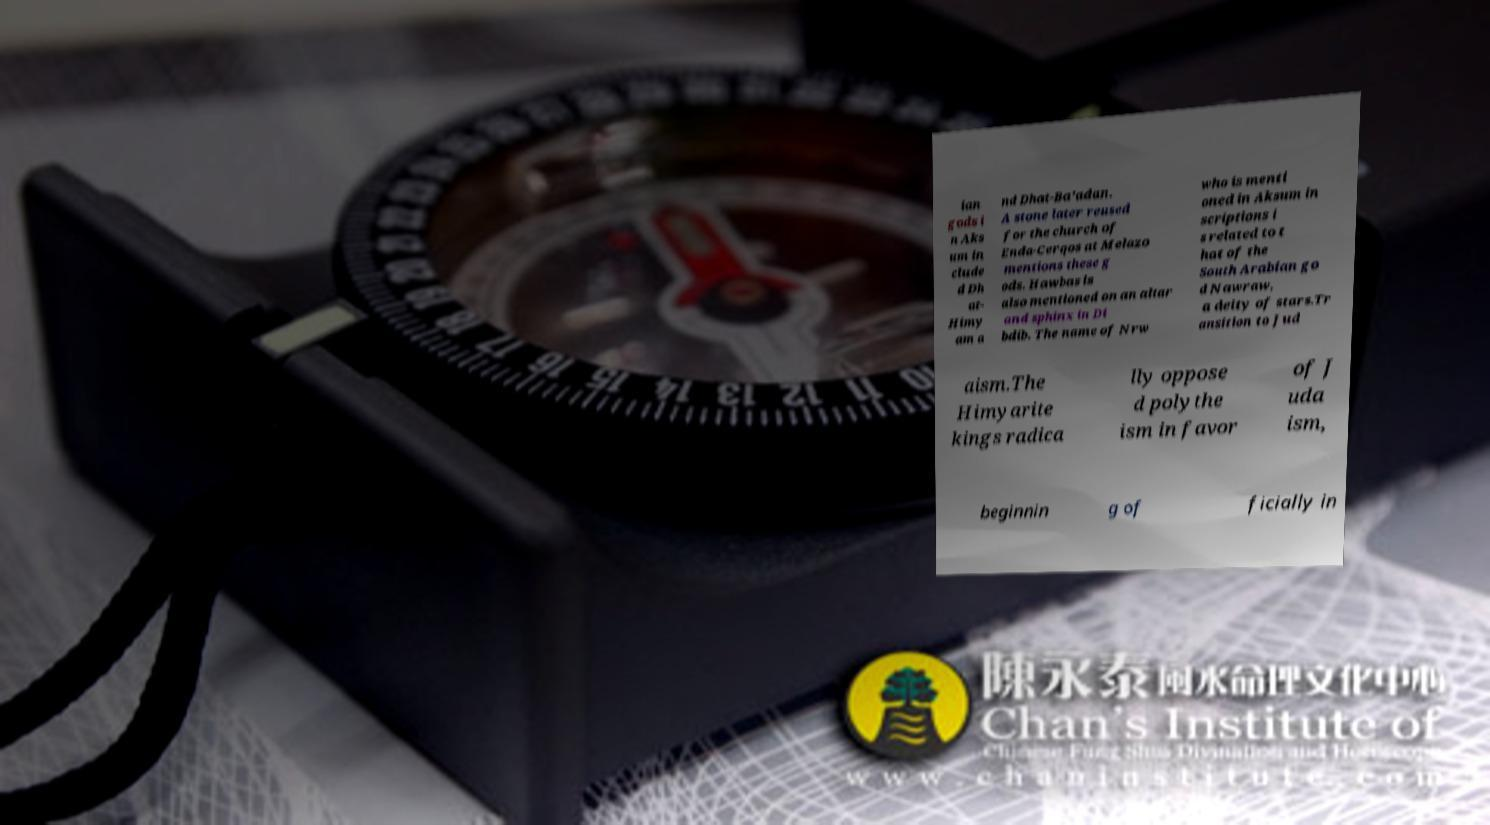Can you read and provide the text displayed in the image?This photo seems to have some interesting text. Can you extract and type it out for me? ian gods i n Aks um in clude d Dh at- Himy am a nd Dhat-Ba'adan. A stone later reused for the church of Enda-Cerqos at Melazo mentions these g ods. Hawbas is also mentioned on an altar and sphinx in Di bdib. The name of Nrw who is menti oned in Aksum in scriptions i s related to t hat of the South Arabian go d Nawraw, a deity of stars.Tr ansition to Jud aism.The Himyarite kings radica lly oppose d polythe ism in favor of J uda ism, beginnin g of ficially in 